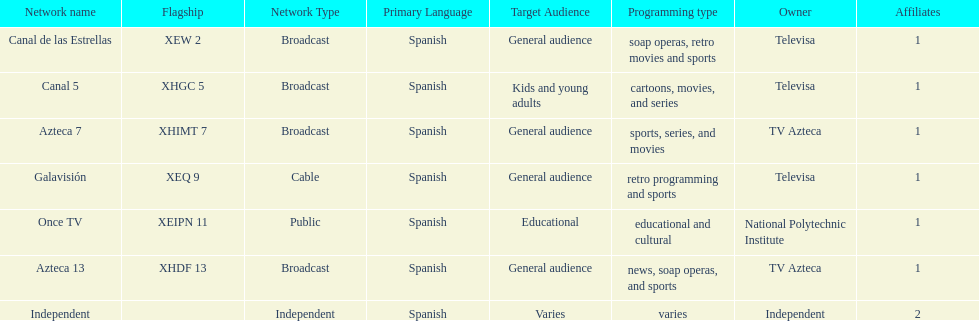How many networks does televisa possess? 3. 